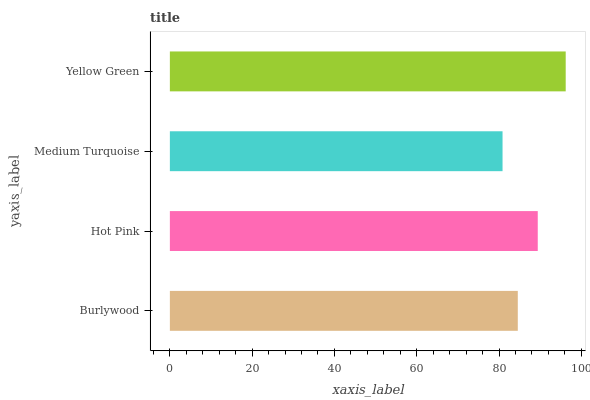Is Medium Turquoise the minimum?
Answer yes or no. Yes. Is Yellow Green the maximum?
Answer yes or no. Yes. Is Hot Pink the minimum?
Answer yes or no. No. Is Hot Pink the maximum?
Answer yes or no. No. Is Hot Pink greater than Burlywood?
Answer yes or no. Yes. Is Burlywood less than Hot Pink?
Answer yes or no. Yes. Is Burlywood greater than Hot Pink?
Answer yes or no. No. Is Hot Pink less than Burlywood?
Answer yes or no. No. Is Hot Pink the high median?
Answer yes or no. Yes. Is Burlywood the low median?
Answer yes or no. Yes. Is Burlywood the high median?
Answer yes or no. No. Is Medium Turquoise the low median?
Answer yes or no. No. 